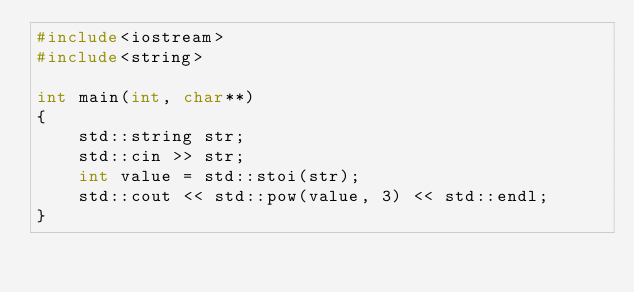<code> <loc_0><loc_0><loc_500><loc_500><_C++_>#include<iostream>
#include<string>

int main(int, char**)
{
    std::string str;
    std::cin >> str;
    int value = std::stoi(str);
    std::cout << std::pow(value, 3) << std::endl;
}
</code> 